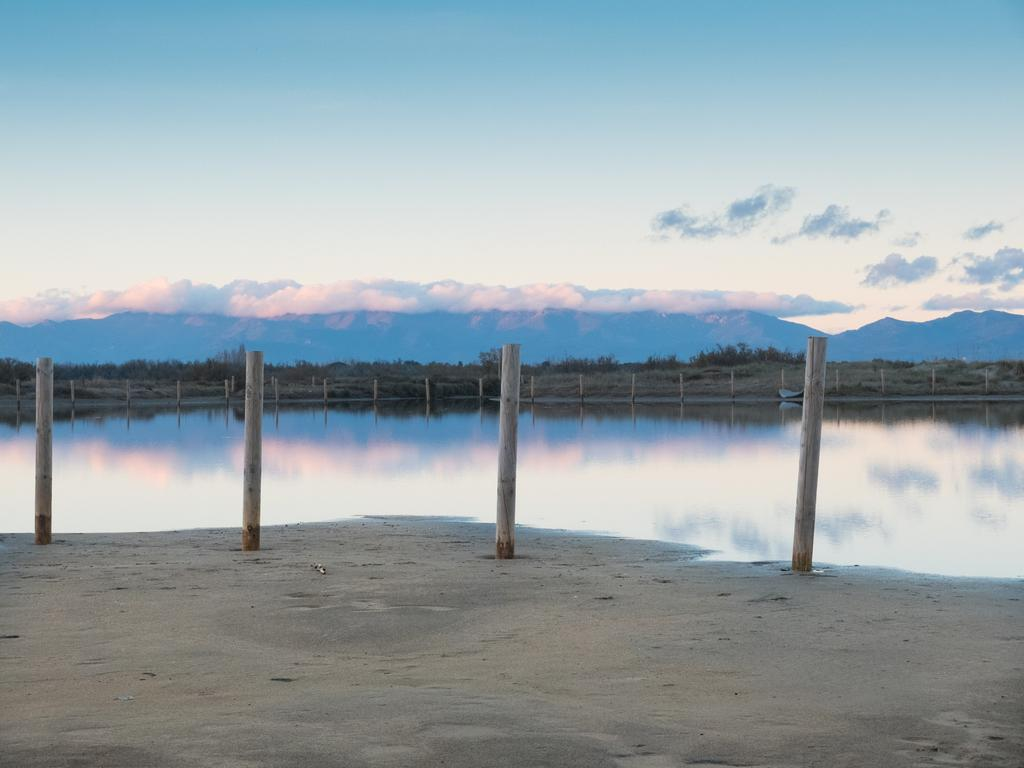What type of terrain can be seen in the image? Ground is visible in the image. What structures are present in the image? There are poles in the image. What natural element is present in the image? There is water in the image. What type of vegetation is in the image? There are plants in the image. What geographical feature can be seen in the distance? There are mountains in the image. What part of the natural environment is visible in the image? The sky is visible in the image. What atmospheric conditions can be observed in the sky? Clouds are present in the sky. What advice is being given by the ocean in the image? There is no ocean present in the image, so no advice can be given by it. What emotion is displayed by the clouds in the image? The clouds in the image do not display emotions; they are simply a natural atmospheric phenomenon. 